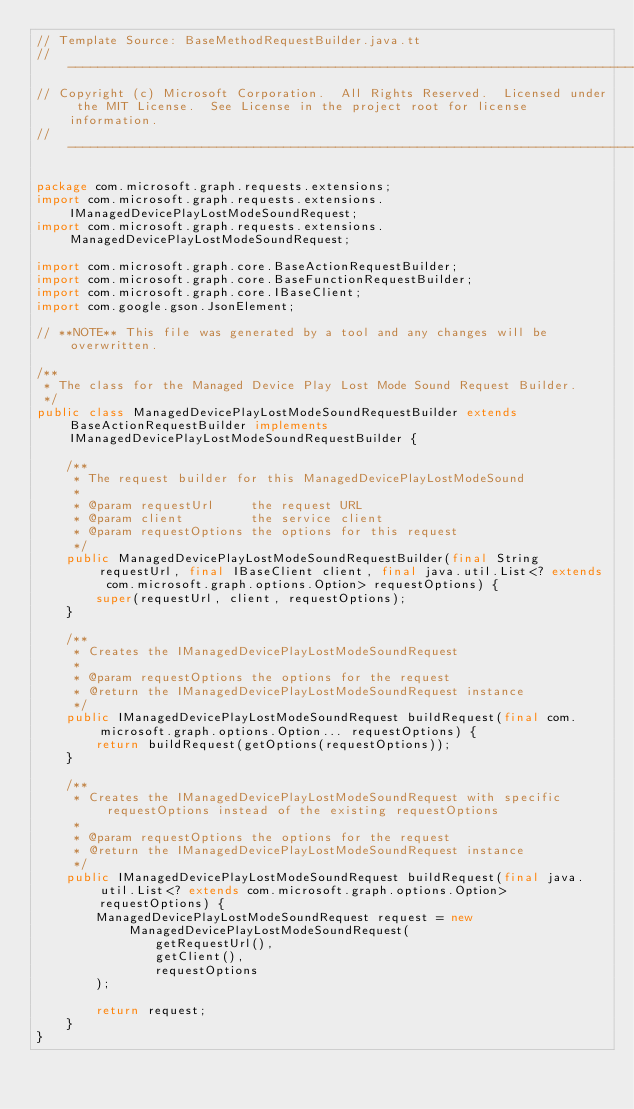Convert code to text. <code><loc_0><loc_0><loc_500><loc_500><_Java_>// Template Source: BaseMethodRequestBuilder.java.tt
// ------------------------------------------------------------------------------
// Copyright (c) Microsoft Corporation.  All Rights Reserved.  Licensed under the MIT License.  See License in the project root for license information.
// ------------------------------------------------------------------------------

package com.microsoft.graph.requests.extensions;
import com.microsoft.graph.requests.extensions.IManagedDevicePlayLostModeSoundRequest;
import com.microsoft.graph.requests.extensions.ManagedDevicePlayLostModeSoundRequest;

import com.microsoft.graph.core.BaseActionRequestBuilder;
import com.microsoft.graph.core.BaseFunctionRequestBuilder;
import com.microsoft.graph.core.IBaseClient;
import com.google.gson.JsonElement;

// **NOTE** This file was generated by a tool and any changes will be overwritten.

/**
 * The class for the Managed Device Play Lost Mode Sound Request Builder.
 */
public class ManagedDevicePlayLostModeSoundRequestBuilder extends BaseActionRequestBuilder implements IManagedDevicePlayLostModeSoundRequestBuilder {

    /**
     * The request builder for this ManagedDevicePlayLostModeSound
     *
     * @param requestUrl     the request URL
     * @param client         the service client
     * @param requestOptions the options for this request
     */
    public ManagedDevicePlayLostModeSoundRequestBuilder(final String requestUrl, final IBaseClient client, final java.util.List<? extends com.microsoft.graph.options.Option> requestOptions) {
        super(requestUrl, client, requestOptions);
    }

    /**
     * Creates the IManagedDevicePlayLostModeSoundRequest
     *
     * @param requestOptions the options for the request
     * @return the IManagedDevicePlayLostModeSoundRequest instance
     */
    public IManagedDevicePlayLostModeSoundRequest buildRequest(final com.microsoft.graph.options.Option... requestOptions) {
        return buildRequest(getOptions(requestOptions));
    }

    /**
     * Creates the IManagedDevicePlayLostModeSoundRequest with specific requestOptions instead of the existing requestOptions
     *
     * @param requestOptions the options for the request
     * @return the IManagedDevicePlayLostModeSoundRequest instance
     */
    public IManagedDevicePlayLostModeSoundRequest buildRequest(final java.util.List<? extends com.microsoft.graph.options.Option> requestOptions) {
        ManagedDevicePlayLostModeSoundRequest request = new ManagedDevicePlayLostModeSoundRequest(
                getRequestUrl(),
                getClient(),
                requestOptions
        );

        return request;
    }
}
</code> 